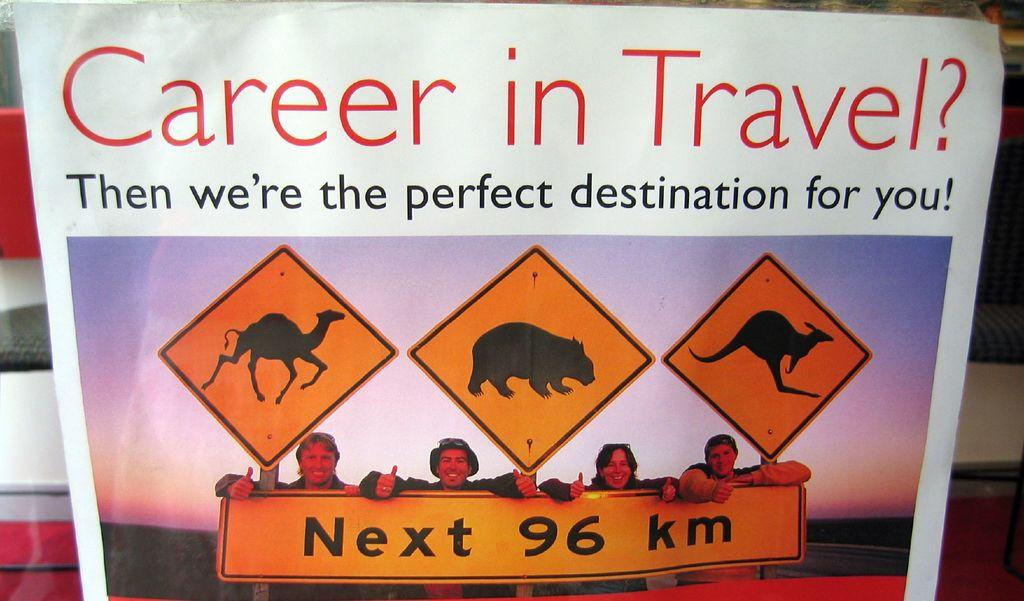Provide a one-sentence caption for the provided image. A sign advertises a career in travel showing 4 works standing in front of a road sign featuring pictures of animals. 